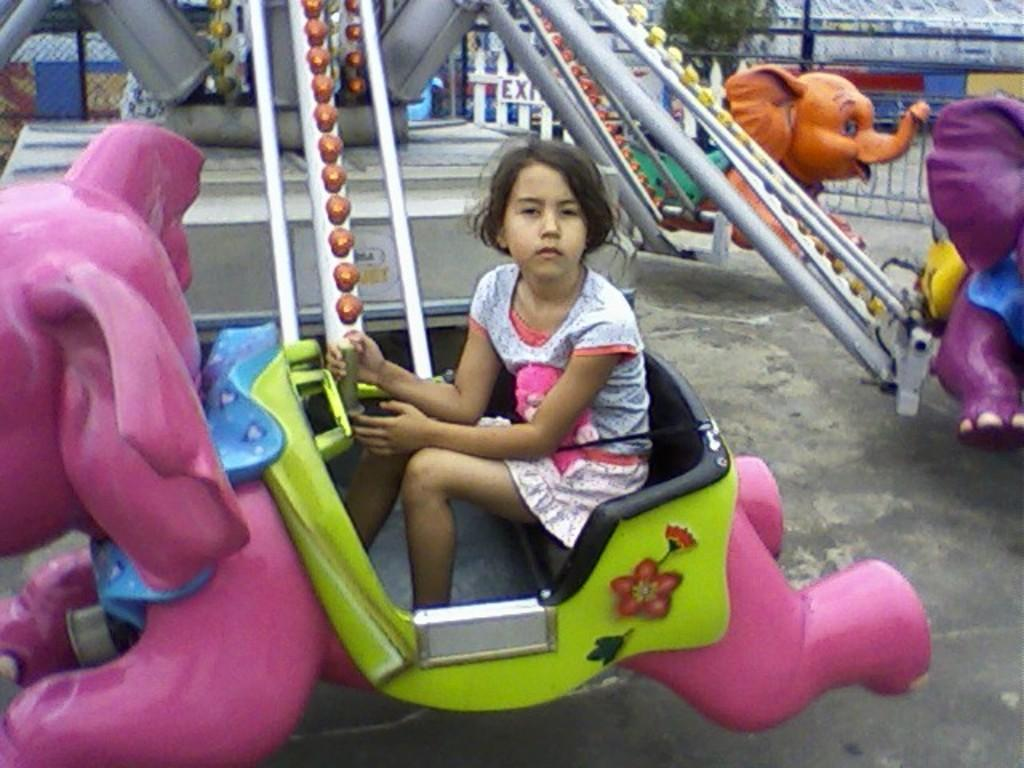What is the girl in the image doing? The girl is sitting in the amusement park ride. What can be seen in the background of the image? There is a tree visible in the background. What type of barrier is present in the image? There is a metal fence in the image. What is written or displayed on the board in the image? There is a board with some text in the image. Reasoning: Let'g: Let's think step by step in order to produce the conversation. We start by identifying the main subject in the image, which is the girl sitting in the amusement park ride. Then, we expand the conversation to include other elements in the image, such as the tree in the background, the metal fence, and the board with text. Each question is designed to elicit a specific detail about the image that is known from the provided facts. Absurd Question/Answer: What type of grass is growing in the wilderness area of the image? There is no wilderness area or grass present in the image. 